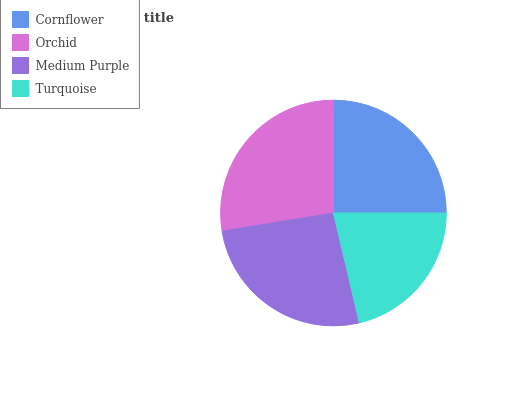Is Turquoise the minimum?
Answer yes or no. Yes. Is Orchid the maximum?
Answer yes or no. Yes. Is Medium Purple the minimum?
Answer yes or no. No. Is Medium Purple the maximum?
Answer yes or no. No. Is Orchid greater than Medium Purple?
Answer yes or no. Yes. Is Medium Purple less than Orchid?
Answer yes or no. Yes. Is Medium Purple greater than Orchid?
Answer yes or no. No. Is Orchid less than Medium Purple?
Answer yes or no. No. Is Medium Purple the high median?
Answer yes or no. Yes. Is Cornflower the low median?
Answer yes or no. Yes. Is Cornflower the high median?
Answer yes or no. No. Is Orchid the low median?
Answer yes or no. No. 